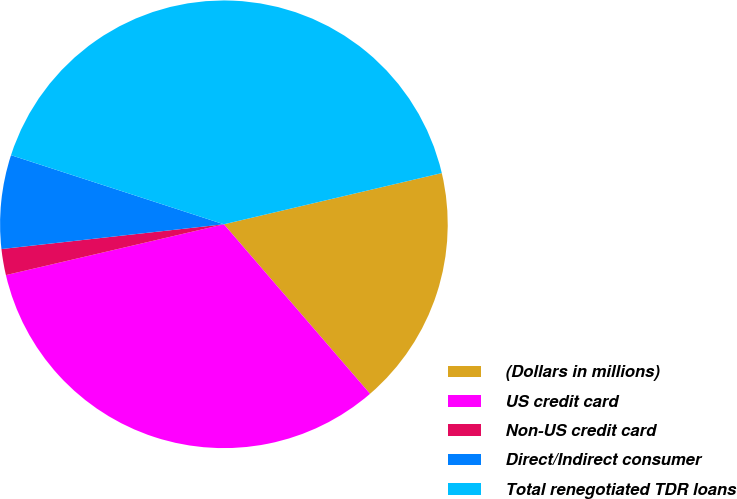<chart> <loc_0><loc_0><loc_500><loc_500><pie_chart><fcel>(Dollars in millions)<fcel>US credit card<fcel>Non-US credit card<fcel>Direct/Indirect consumer<fcel>Total renegotiated TDR loans<nl><fcel>17.35%<fcel>32.68%<fcel>1.88%<fcel>6.76%<fcel>41.33%<nl></chart> 